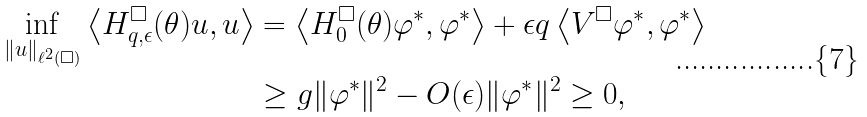Convert formula to latex. <formula><loc_0><loc_0><loc_500><loc_500>\inf _ { \| u \| _ { \ell ^ { 2 } ( \square ) } } \left \langle H _ { q , \epsilon } ^ { \square } ( \theta ) u , u \right \rangle & = \left \langle H _ { 0 } ^ { \square } ( \theta ) \varphi ^ { * } , \varphi ^ { * } \right \rangle + \epsilon q \left \langle V ^ { \square } \varphi ^ { * } , \varphi ^ { * } \right \rangle \\ & \geq g \| \varphi ^ { * } \| ^ { 2 } - O ( \epsilon ) \| \varphi ^ { * } \| ^ { 2 } \geq 0 ,</formula> 